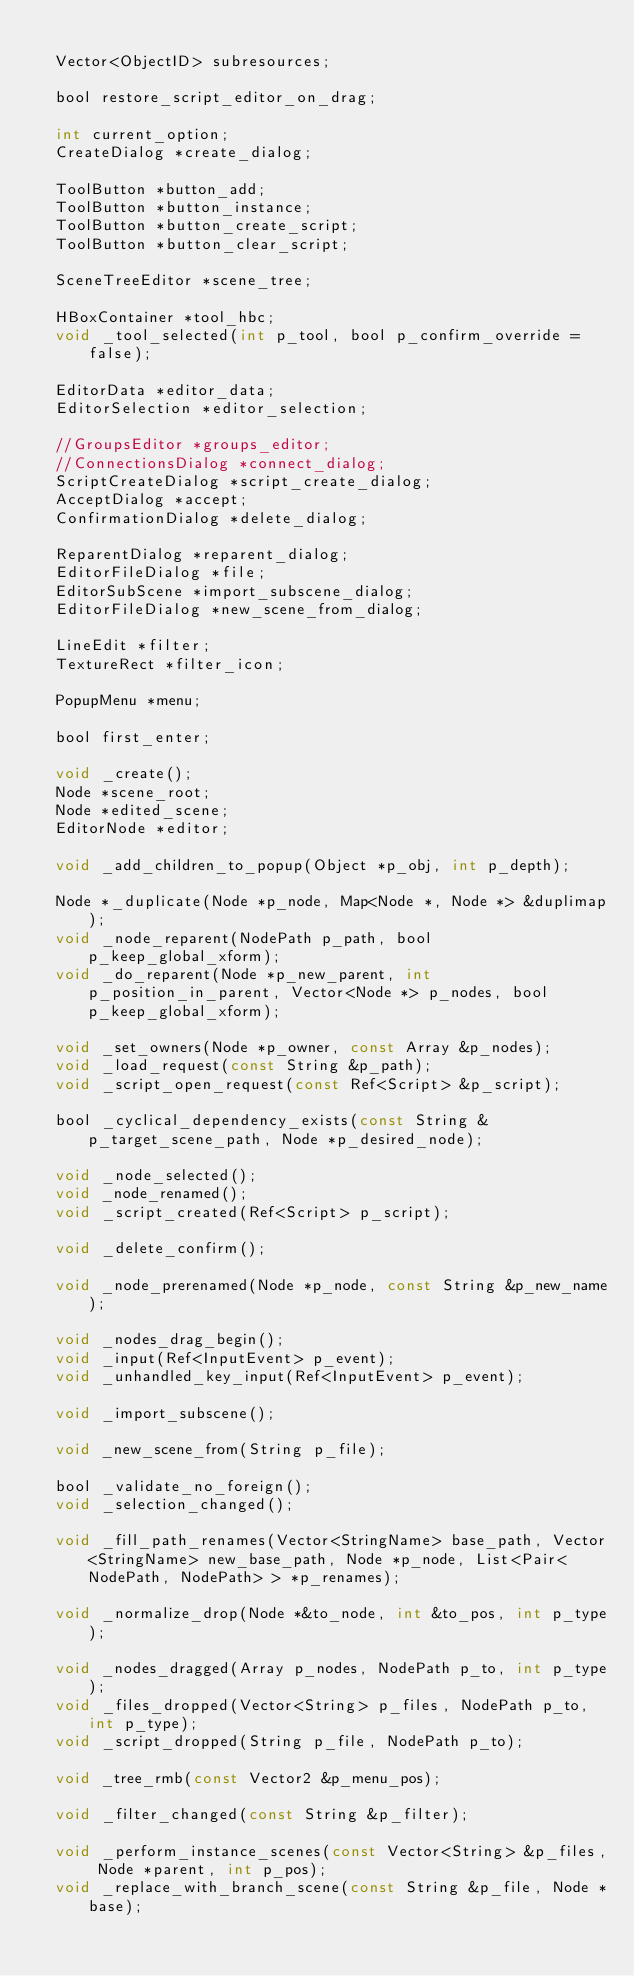Convert code to text. <code><loc_0><loc_0><loc_500><loc_500><_C_>
	Vector<ObjectID> subresources;

	bool restore_script_editor_on_drag;

	int current_option;
	CreateDialog *create_dialog;

	ToolButton *button_add;
	ToolButton *button_instance;
	ToolButton *button_create_script;
	ToolButton *button_clear_script;

	SceneTreeEditor *scene_tree;

	HBoxContainer *tool_hbc;
	void _tool_selected(int p_tool, bool p_confirm_override = false);

	EditorData *editor_data;
	EditorSelection *editor_selection;

	//GroupsEditor *groups_editor;
	//ConnectionsDialog *connect_dialog;
	ScriptCreateDialog *script_create_dialog;
	AcceptDialog *accept;
	ConfirmationDialog *delete_dialog;

	ReparentDialog *reparent_dialog;
	EditorFileDialog *file;
	EditorSubScene *import_subscene_dialog;
	EditorFileDialog *new_scene_from_dialog;

	LineEdit *filter;
	TextureRect *filter_icon;

	PopupMenu *menu;

	bool first_enter;

	void _create();
	Node *scene_root;
	Node *edited_scene;
	EditorNode *editor;

	void _add_children_to_popup(Object *p_obj, int p_depth);

	Node *_duplicate(Node *p_node, Map<Node *, Node *> &duplimap);
	void _node_reparent(NodePath p_path, bool p_keep_global_xform);
	void _do_reparent(Node *p_new_parent, int p_position_in_parent, Vector<Node *> p_nodes, bool p_keep_global_xform);

	void _set_owners(Node *p_owner, const Array &p_nodes);
	void _load_request(const String &p_path);
	void _script_open_request(const Ref<Script> &p_script);

	bool _cyclical_dependency_exists(const String &p_target_scene_path, Node *p_desired_node);

	void _node_selected();
	void _node_renamed();
	void _script_created(Ref<Script> p_script);

	void _delete_confirm();

	void _node_prerenamed(Node *p_node, const String &p_new_name);

	void _nodes_drag_begin();
	void _input(Ref<InputEvent> p_event);
	void _unhandled_key_input(Ref<InputEvent> p_event);

	void _import_subscene();

	void _new_scene_from(String p_file);

	bool _validate_no_foreign();
	void _selection_changed();

	void _fill_path_renames(Vector<StringName> base_path, Vector<StringName> new_base_path, Node *p_node, List<Pair<NodePath, NodePath> > *p_renames);

	void _normalize_drop(Node *&to_node, int &to_pos, int p_type);

	void _nodes_dragged(Array p_nodes, NodePath p_to, int p_type);
	void _files_dropped(Vector<String> p_files, NodePath p_to, int p_type);
	void _script_dropped(String p_file, NodePath p_to);

	void _tree_rmb(const Vector2 &p_menu_pos);

	void _filter_changed(const String &p_filter);

	void _perform_instance_scenes(const Vector<String> &p_files, Node *parent, int p_pos);
	void _replace_with_branch_scene(const String &p_file, Node *base);
</code> 